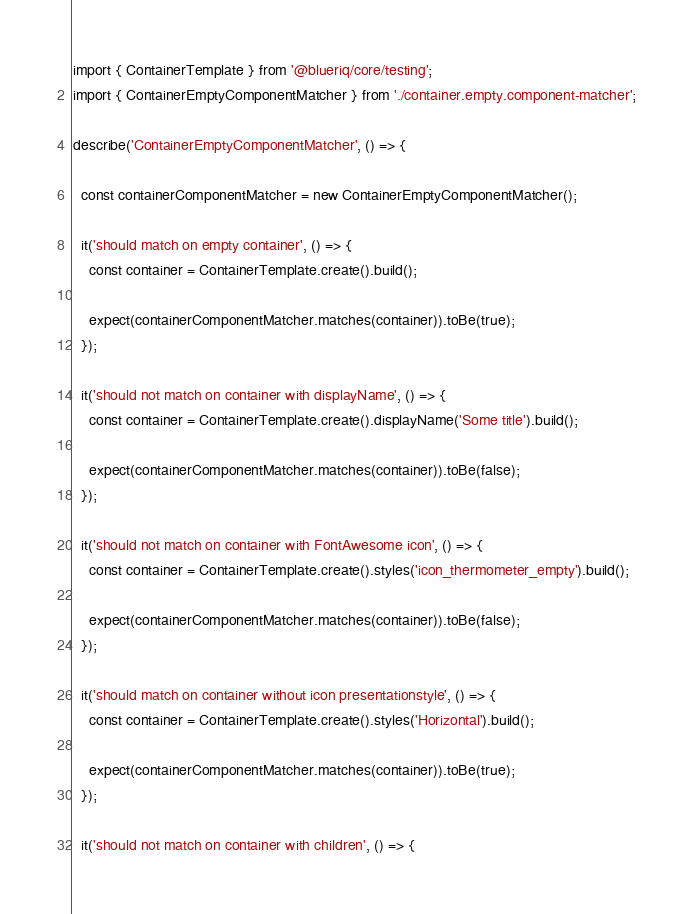Convert code to text. <code><loc_0><loc_0><loc_500><loc_500><_TypeScript_>import { ContainerTemplate } from '@blueriq/core/testing';
import { ContainerEmptyComponentMatcher } from './container.empty.component-matcher';

describe('ContainerEmptyComponentMatcher', () => {

  const containerComponentMatcher = new ContainerEmptyComponentMatcher();

  it('should match on empty container', () => {
    const container = ContainerTemplate.create().build();

    expect(containerComponentMatcher.matches(container)).toBe(true);
  });

  it('should not match on container with displayName', () => {
    const container = ContainerTemplate.create().displayName('Some title').build();

    expect(containerComponentMatcher.matches(container)).toBe(false);
  });

  it('should not match on container with FontAwesome icon', () => {
    const container = ContainerTemplate.create().styles('icon_thermometer_empty').build();

    expect(containerComponentMatcher.matches(container)).toBe(false);
  });

  it('should match on container without icon presentationstyle', () => {
    const container = ContainerTemplate.create().styles('Horizontal').build();

    expect(containerComponentMatcher.matches(container)).toBe(true);
  });

  it('should not match on container with children', () => {</code> 